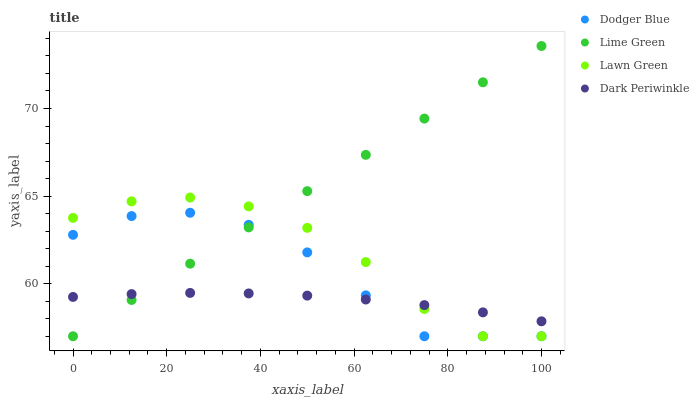Does Dark Periwinkle have the minimum area under the curve?
Answer yes or no. Yes. Does Lime Green have the maximum area under the curve?
Answer yes or no. Yes. Does Dodger Blue have the minimum area under the curve?
Answer yes or no. No. Does Dodger Blue have the maximum area under the curve?
Answer yes or no. No. Is Lime Green the smoothest?
Answer yes or no. Yes. Is Lawn Green the roughest?
Answer yes or no. Yes. Is Dodger Blue the smoothest?
Answer yes or no. No. Is Dodger Blue the roughest?
Answer yes or no. No. Does Lime Green have the lowest value?
Answer yes or no. Yes. Does Dark Periwinkle have the lowest value?
Answer yes or no. No. Does Lime Green have the highest value?
Answer yes or no. Yes. Does Dodger Blue have the highest value?
Answer yes or no. No. Does Dark Periwinkle intersect Dodger Blue?
Answer yes or no. Yes. Is Dark Periwinkle less than Dodger Blue?
Answer yes or no. No. Is Dark Periwinkle greater than Dodger Blue?
Answer yes or no. No. 